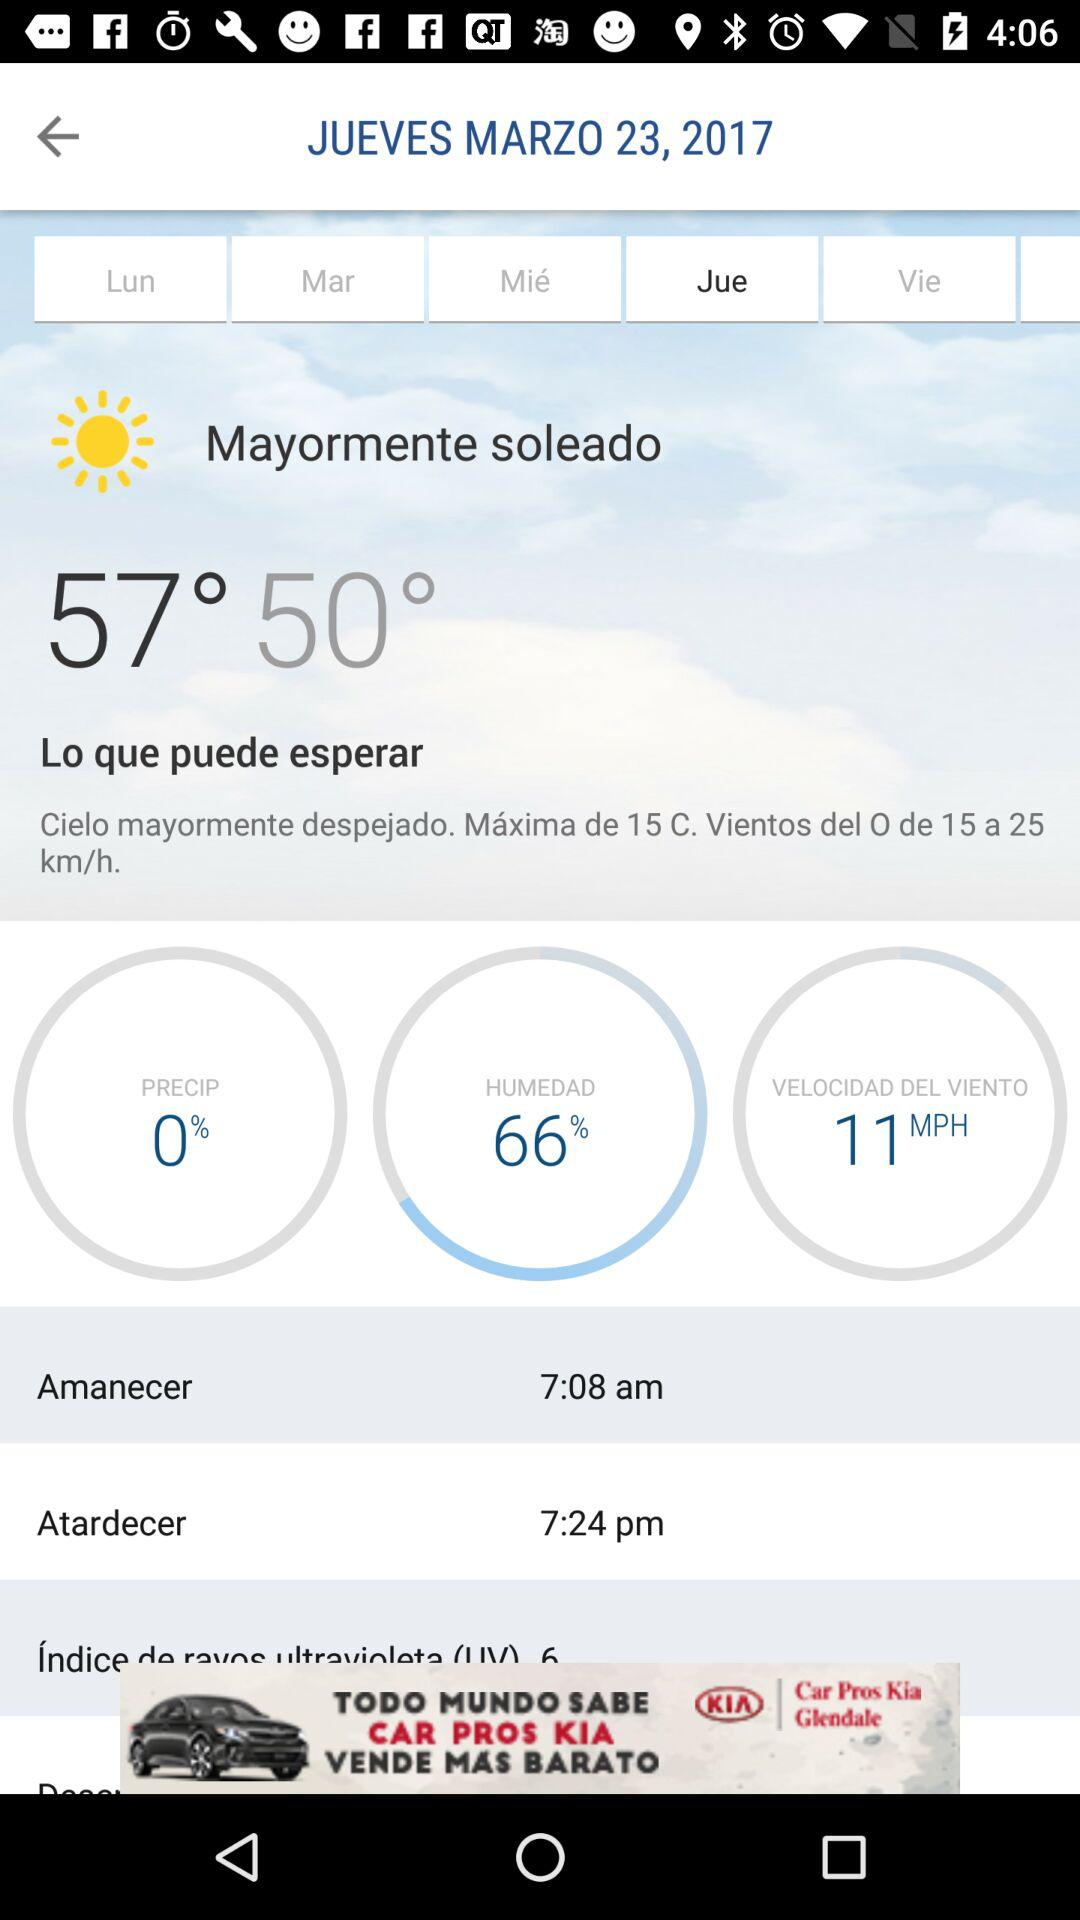What is the UV index?
Answer the question using a single word or phrase. 6 